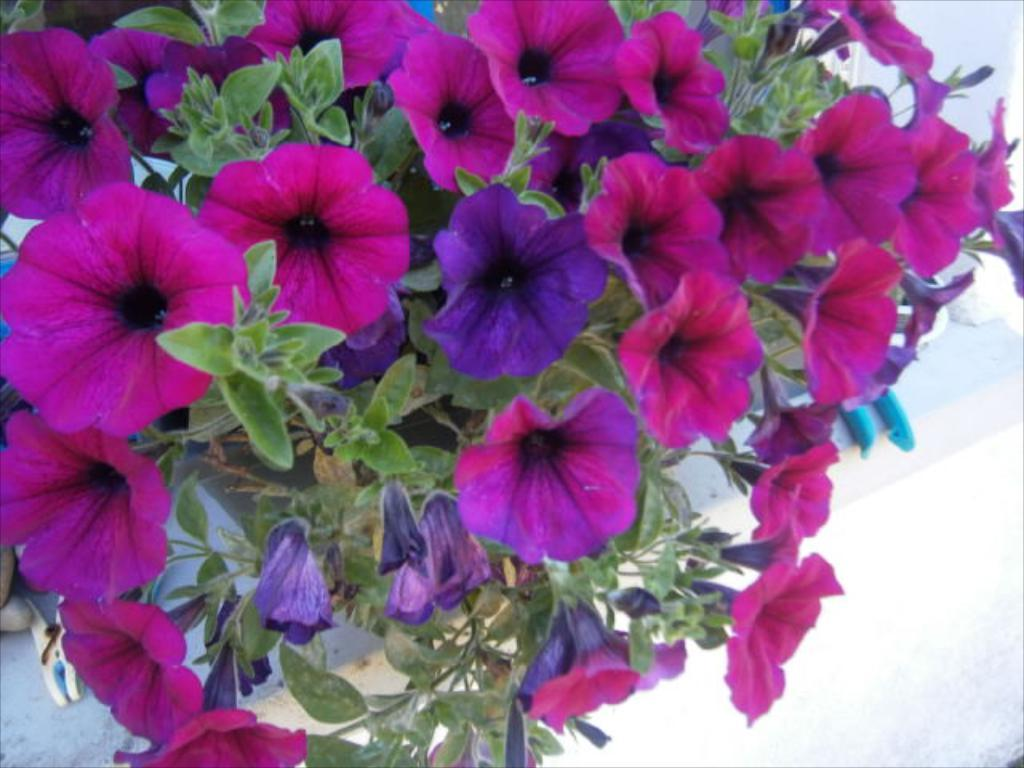What type of plant is in the image? There is a flower plant in the image. What colors are present on the flower plant? The flower plant has pink and purple colors. What can be seen at the bottom of the image? There is a white color wall at the bottom of the image. How does the paper process the flower plant in the image? There is no paper or process mentioned in the image; it features a flower plant with pink and purple colors and a white color wall at the bottom. 